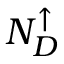<formula> <loc_0><loc_0><loc_500><loc_500>N _ { D } ^ { \uparrow }</formula> 